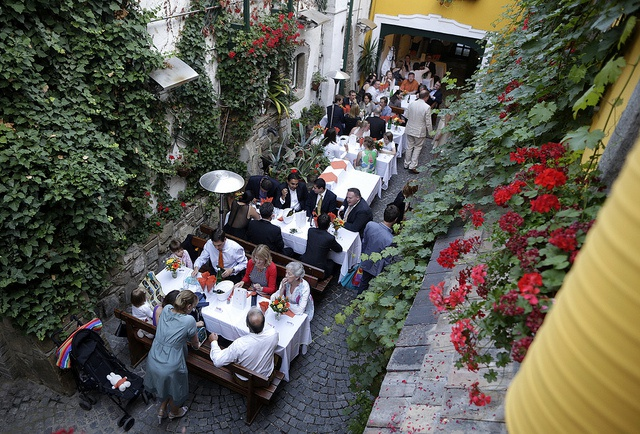Describe the objects in this image and their specific colors. I can see people in black, gray, darkgray, and lavender tones, dining table in black, lavender, darkgray, and gray tones, people in black and gray tones, bench in black and gray tones, and people in black, lavender, and darkgray tones in this image. 